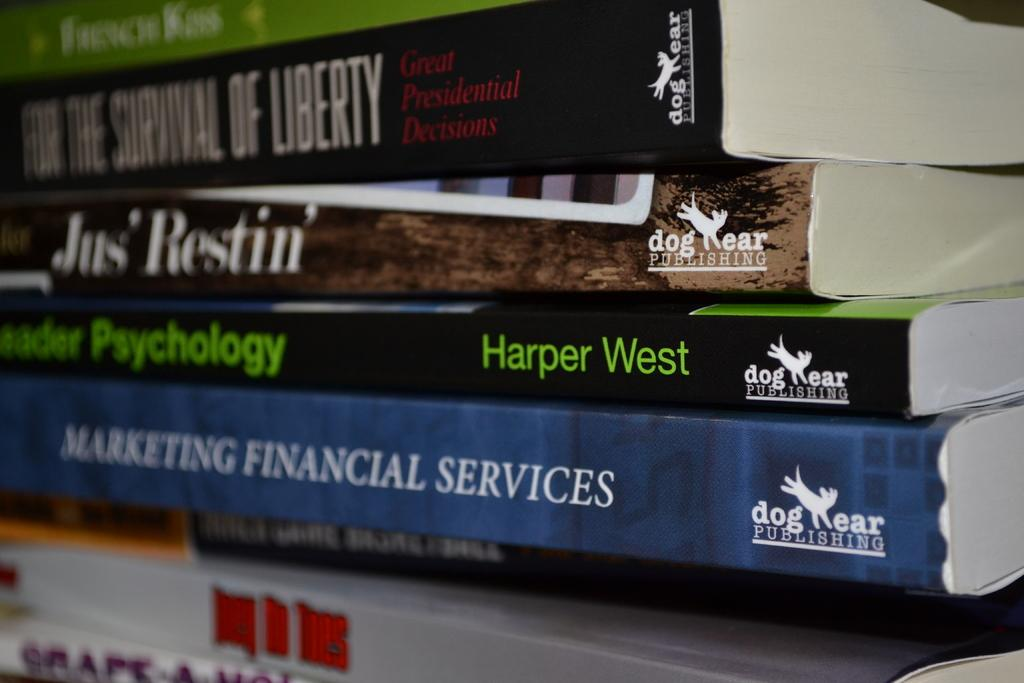<image>
Create a compact narrative representing the image presented. Books placed in a stack with Harper West's Psychology book near the bottom. 